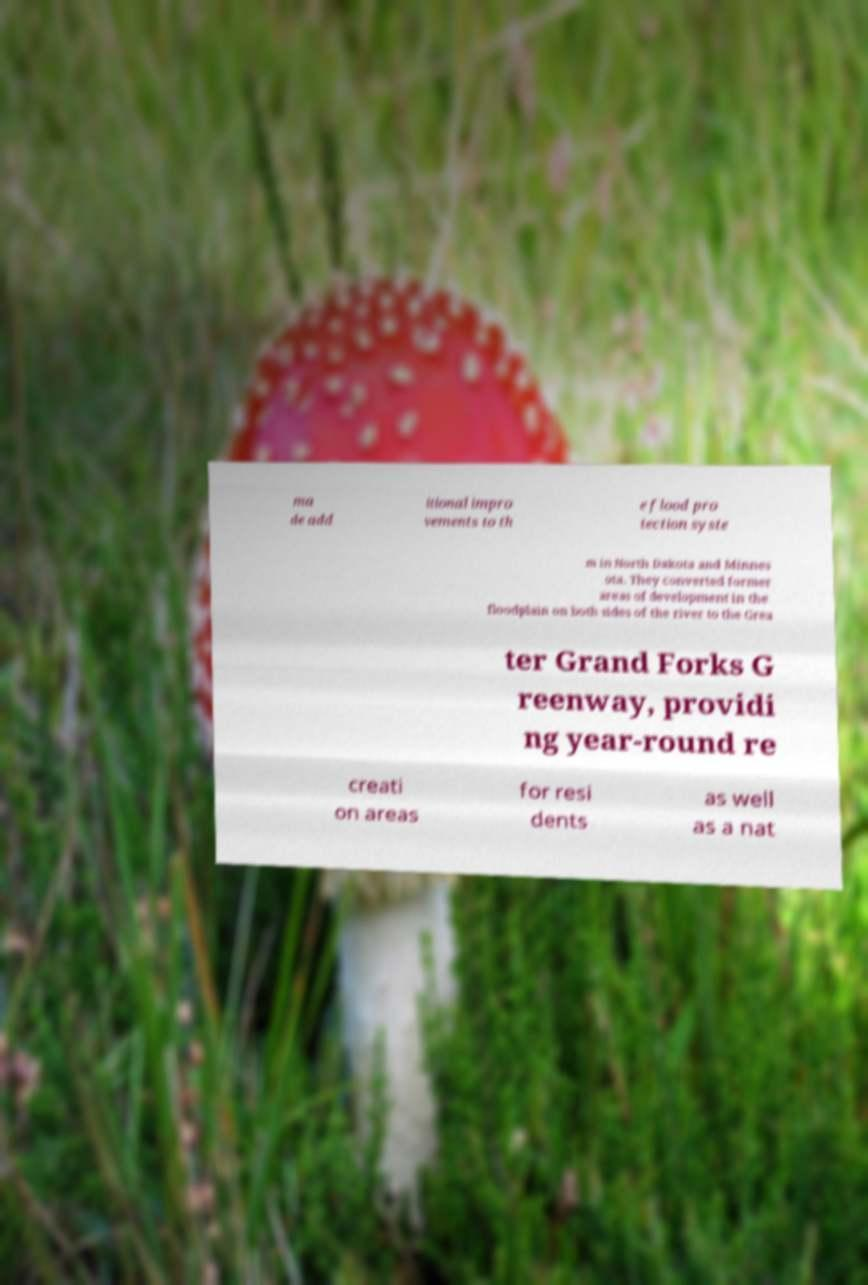Could you assist in decoding the text presented in this image and type it out clearly? ma de add itional impro vements to th e flood pro tection syste m in North Dakota and Minnes ota. They converted former areas of development in the floodplain on both sides of the river to the Grea ter Grand Forks G reenway, providi ng year-round re creati on areas for resi dents as well as a nat 